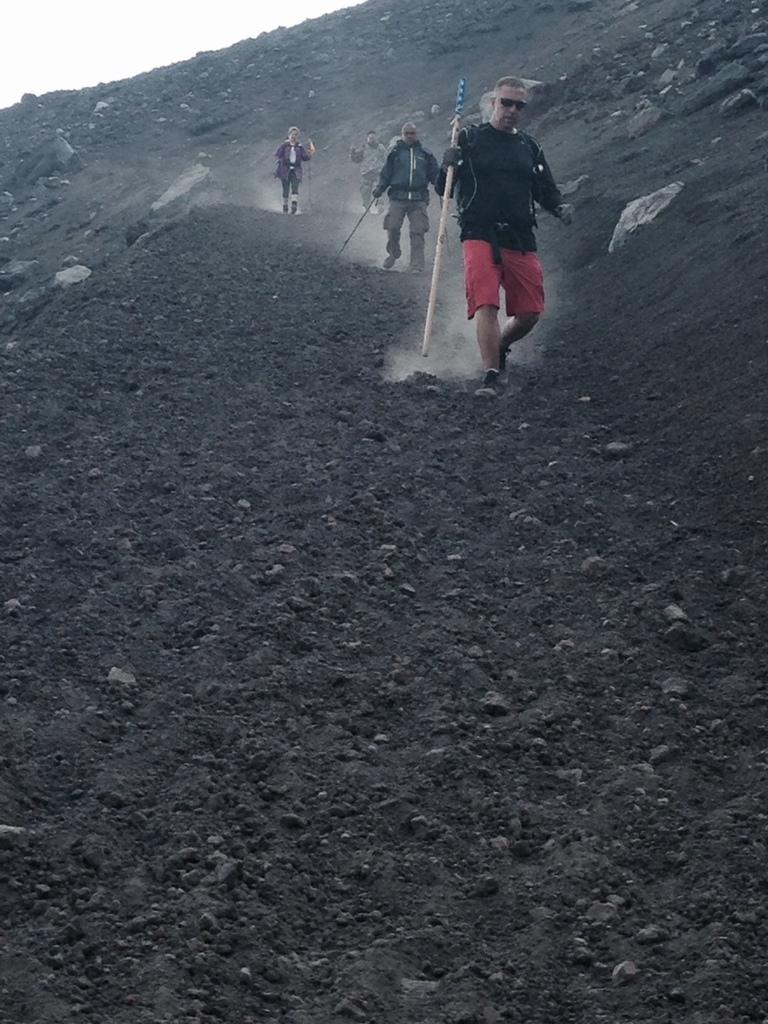How many people are in the image? There are four persons in the image. What are the persons holding in their hands? The persons are holding sticks. Where are the persons walking in the image? The persons are walking on a hill. What can be seen in the background of the image? The sky is visible in the background of the image. What type of bait is being used by the persons in the image? There is no mention of bait or fishing in the image; the persons are holding sticks and walking on a hill. What force is being applied by the persons in the image? The image does not provide information about any force being applied by the persons; they are simply walking on a hill while holding sticks. 